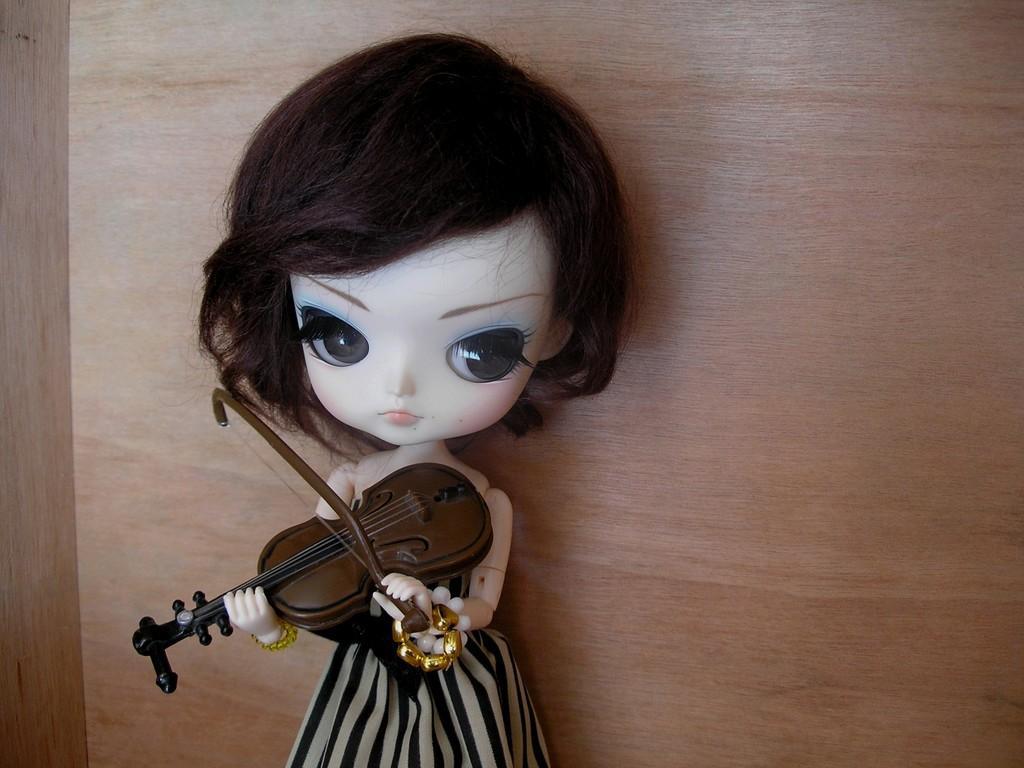Can you describe this image briefly? In this image I can see a doll holding a guitar. 